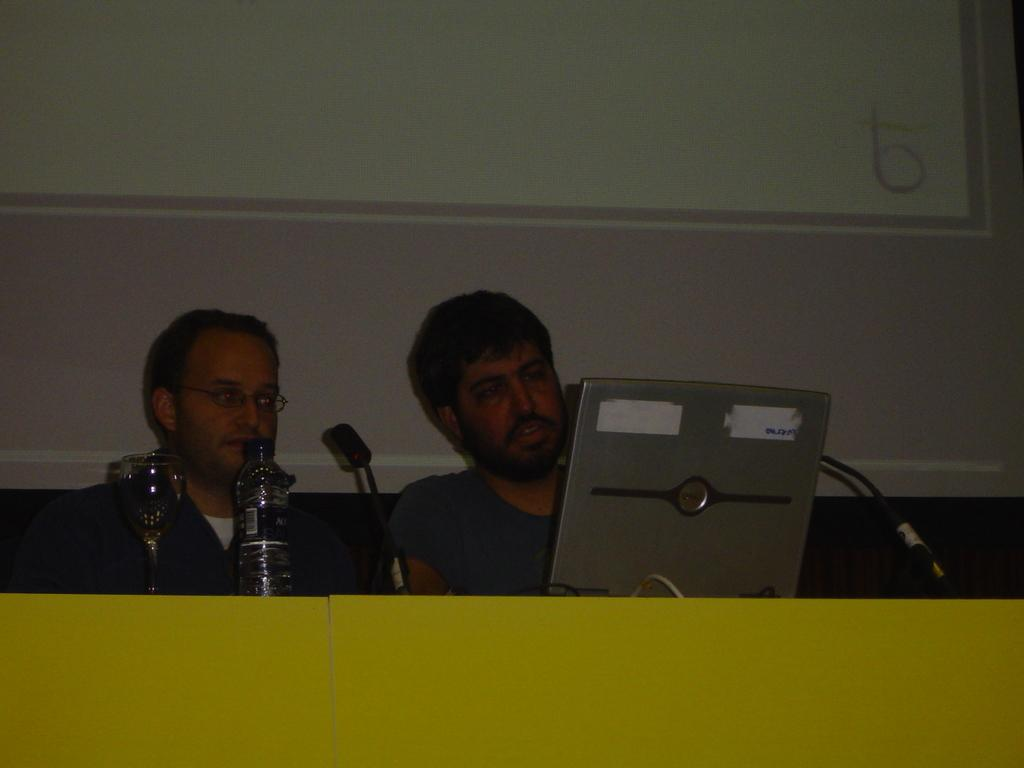How many people are in the image? There are two men in the image. Can you describe one of the men's appearance? One of the men is wearing spectacles. What objects can be seen in the image besides the men? There is a bottle, a glass, and a microphone (mike) in the image. What is visible in the background of the image? There is a screen in the background of the image. Can you tell me how many railway tracks are visible in the image? There are no railway tracks present in the image. What type of nerve is being stimulated by the microphone in the image? There is no nerve being stimulated by the microphone in the image; it is an object used for amplifying sound. 